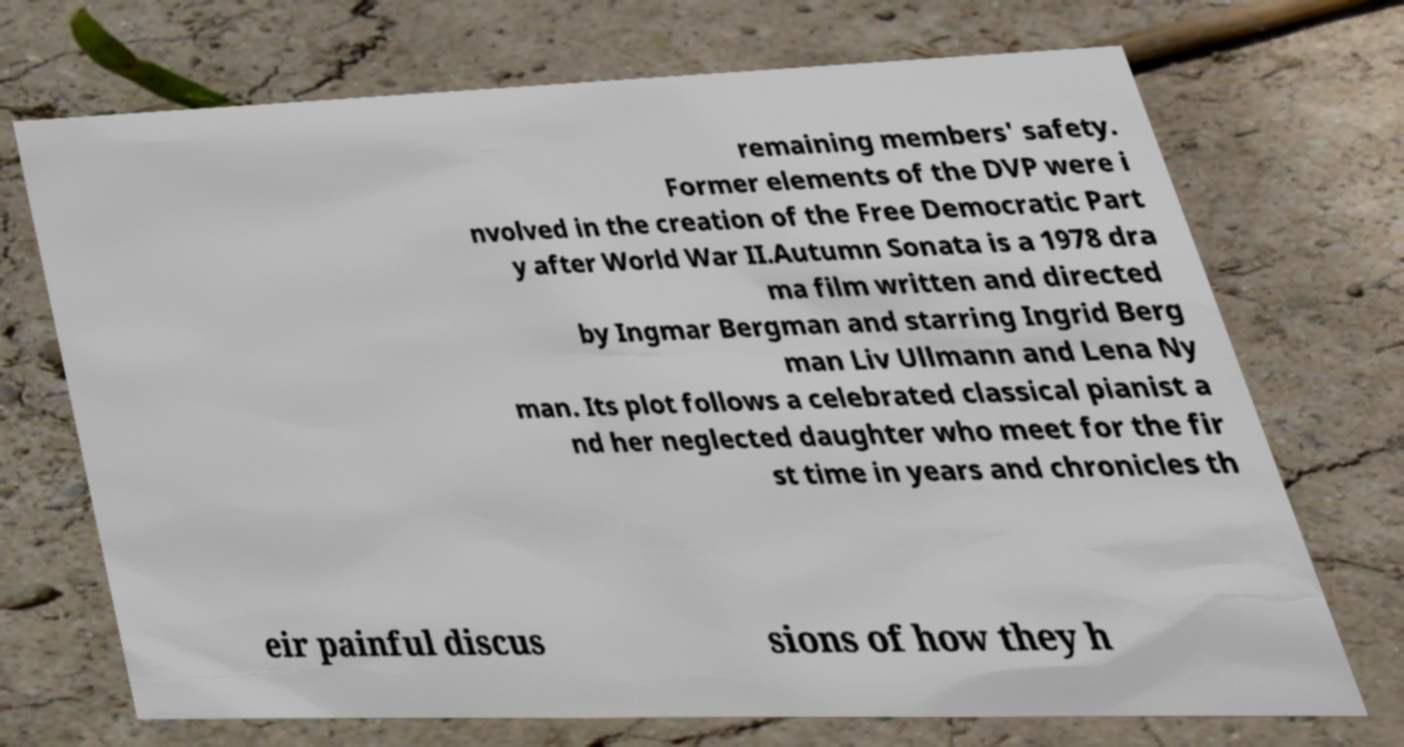Could you assist in decoding the text presented in this image and type it out clearly? remaining members' safety. Former elements of the DVP were i nvolved in the creation of the Free Democratic Part y after World War II.Autumn Sonata is a 1978 dra ma film written and directed by Ingmar Bergman and starring Ingrid Berg man Liv Ullmann and Lena Ny man. Its plot follows a celebrated classical pianist a nd her neglected daughter who meet for the fir st time in years and chronicles th eir painful discus sions of how they h 